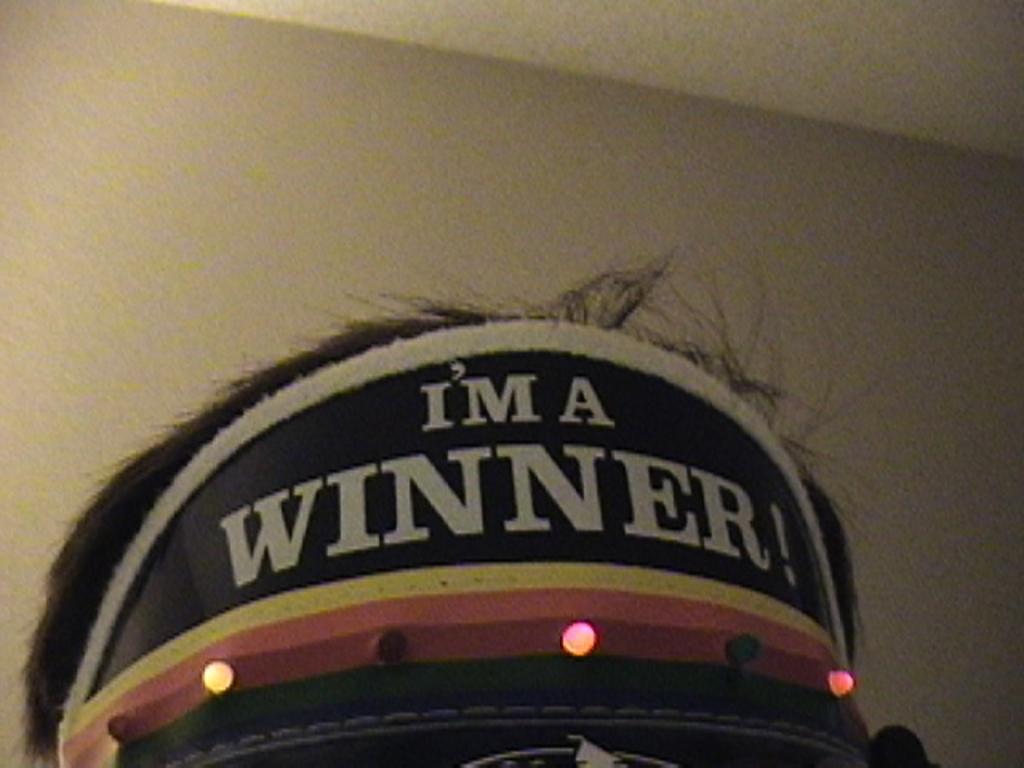In one or two sentences, can you explain what this image depicts? In this image we can see a text written on a cap. 